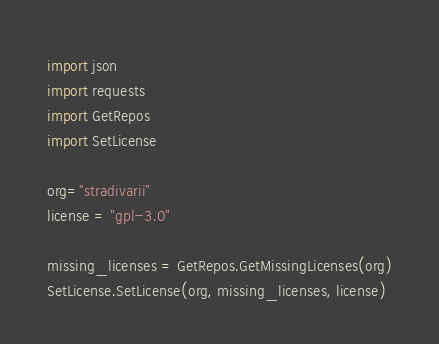<code> <loc_0><loc_0><loc_500><loc_500><_Python_>import json
import requests
import GetRepos
import SetLicense

org="stradivarii"
license = "gpl-3.0"

missing_licenses = GetRepos.GetMissingLicenses(org)
SetLicense.SetLicense(org, missing_licenses, license)
</code> 